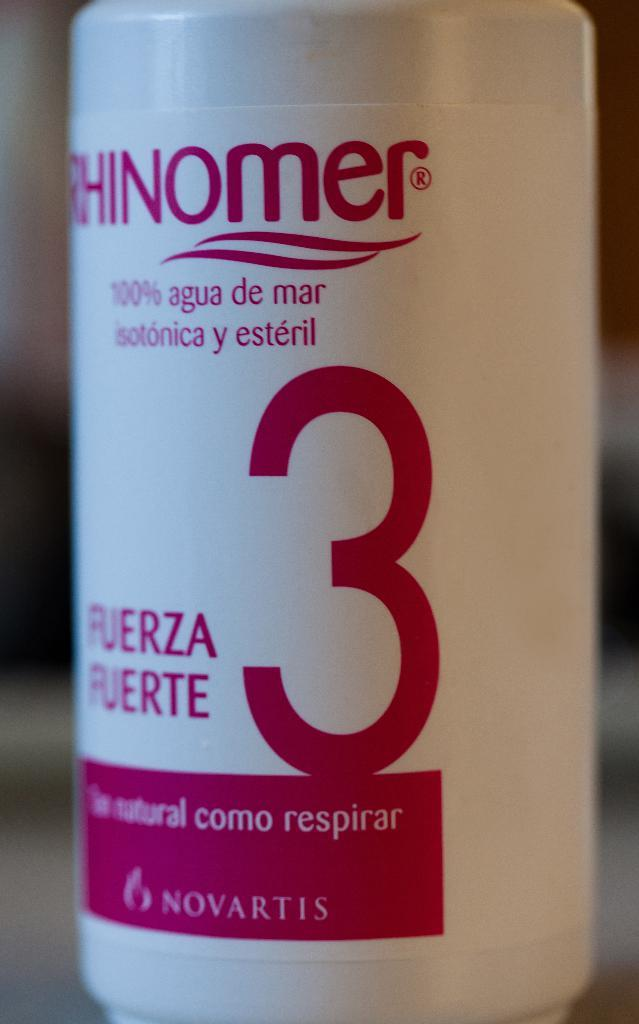<image>
Offer a succinct explanation of the picture presented. A pink and white bottle of Novartis with a large number 3. 